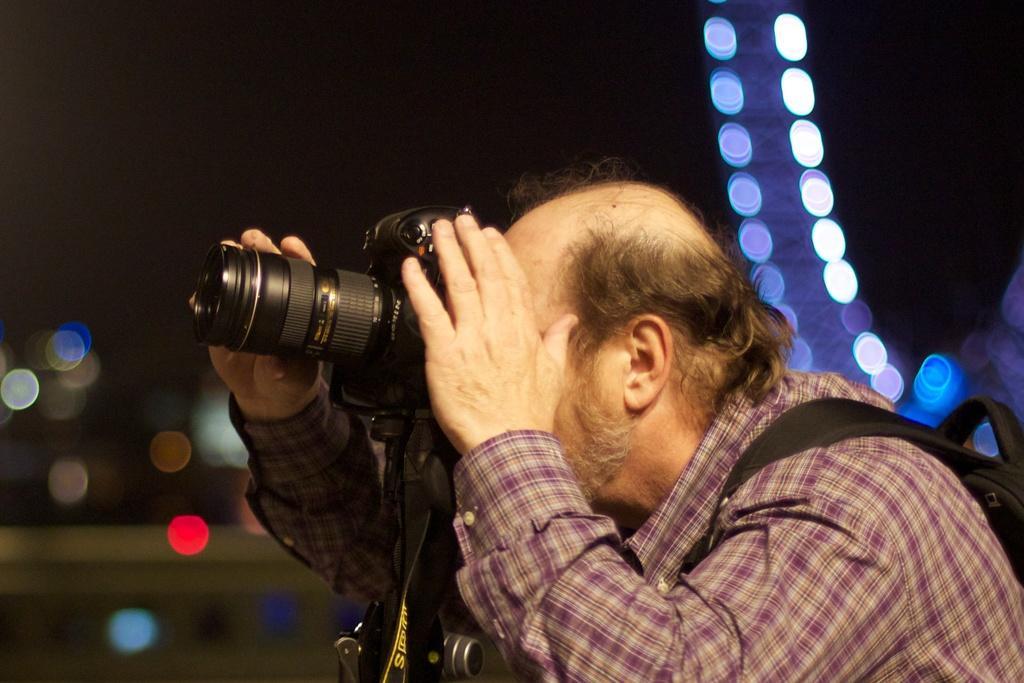Could you give a brief overview of what you see in this image? In this image i can see a man wearing shirt and a bag standing and holding the camera. In the background i can see the dark sky and few lights. 